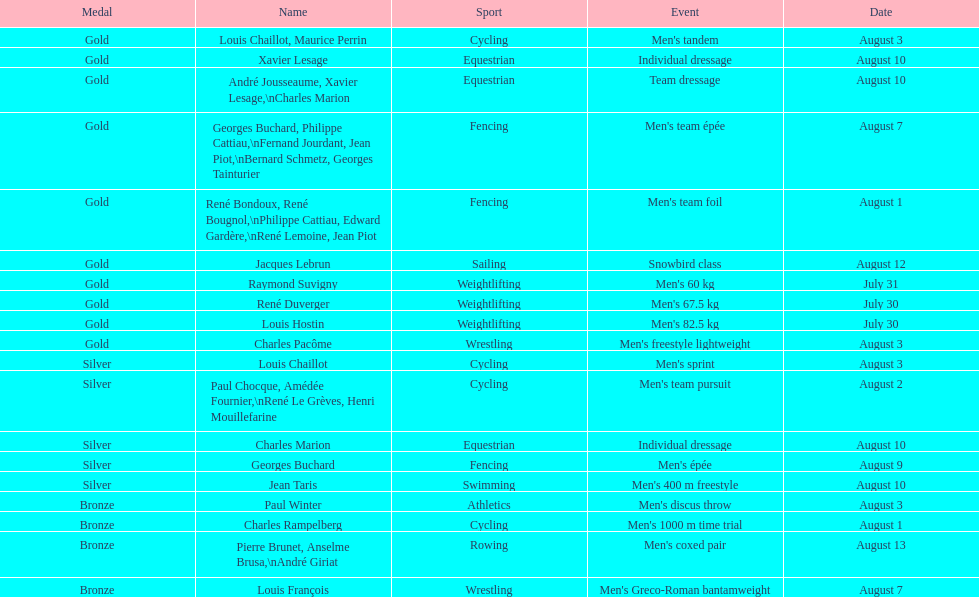Can you parse all the data within this table? {'header': ['Medal', 'Name', 'Sport', 'Event', 'Date'], 'rows': [['Gold', 'Louis Chaillot, Maurice Perrin', 'Cycling', "Men's tandem", 'August 3'], ['Gold', 'Xavier Lesage', 'Equestrian', 'Individual dressage', 'August 10'], ['Gold', 'André Jousseaume, Xavier Lesage,\\nCharles Marion', 'Equestrian', 'Team dressage', 'August 10'], ['Gold', 'Georges Buchard, Philippe Cattiau,\\nFernand Jourdant, Jean Piot,\\nBernard Schmetz, Georges Tainturier', 'Fencing', "Men's team épée", 'August 7'], ['Gold', 'René Bondoux, René Bougnol,\\nPhilippe Cattiau, Edward Gardère,\\nRené Lemoine, Jean Piot', 'Fencing', "Men's team foil", 'August 1'], ['Gold', 'Jacques Lebrun', 'Sailing', 'Snowbird class', 'August 12'], ['Gold', 'Raymond Suvigny', 'Weightlifting', "Men's 60 kg", 'July 31'], ['Gold', 'René Duverger', 'Weightlifting', "Men's 67.5 kg", 'July 30'], ['Gold', 'Louis Hostin', 'Weightlifting', "Men's 82.5 kg", 'July 30'], ['Gold', 'Charles Pacôme', 'Wrestling', "Men's freestyle lightweight", 'August 3'], ['Silver', 'Louis Chaillot', 'Cycling', "Men's sprint", 'August 3'], ['Silver', 'Paul Chocque, Amédée Fournier,\\nRené Le Grèves, Henri Mouillefarine', 'Cycling', "Men's team pursuit", 'August 2'], ['Silver', 'Charles Marion', 'Equestrian', 'Individual dressage', 'August 10'], ['Silver', 'Georges Buchard', 'Fencing', "Men's épée", 'August 9'], ['Silver', 'Jean Taris', 'Swimming', "Men's 400 m freestyle", 'August 10'], ['Bronze', 'Paul Winter', 'Athletics', "Men's discus throw", 'August 3'], ['Bronze', 'Charles Rampelberg', 'Cycling', "Men's 1000 m time trial", 'August 1'], ['Bronze', 'Pierre Brunet, Anselme Brusa,\\nAndré Giriat', 'Rowing', "Men's coxed pair", 'August 13'], ['Bronze', 'Louis François', 'Wrestling', "Men's Greco-Roman bantamweight", 'August 7']]} What is next date that is listed after august 7th? August 1. 